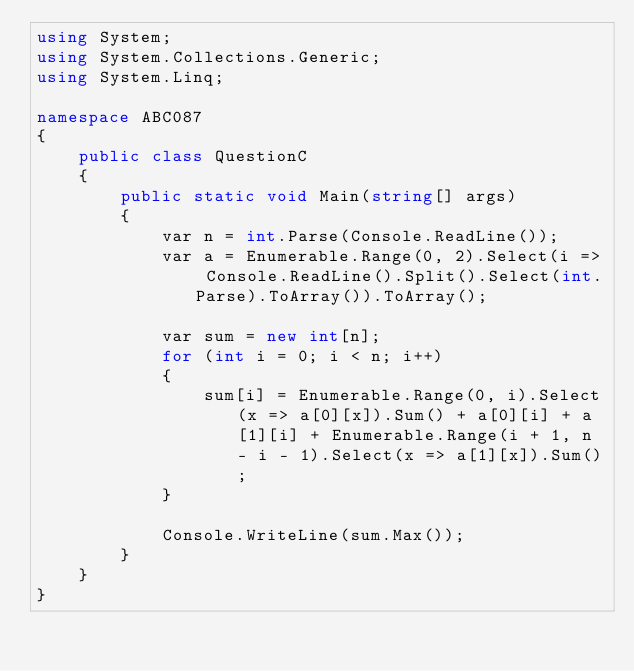<code> <loc_0><loc_0><loc_500><loc_500><_C#_>using System;
using System.Collections.Generic;
using System.Linq;

namespace ABC087
{
    public class QuestionC
    {
        public static void Main(string[] args)
        {
            var n = int.Parse(Console.ReadLine());
            var a = Enumerable.Range(0, 2).Select(i => Console.ReadLine().Split().Select(int.Parse).ToArray()).ToArray();

            var sum = new int[n];
            for (int i = 0; i < n; i++)
            {
                sum[i] = Enumerable.Range(0, i).Select(x => a[0][x]).Sum() + a[0][i] + a[1][i] + Enumerable.Range(i + 1, n - i - 1).Select(x => a[1][x]).Sum();
            }

            Console.WriteLine(sum.Max());
        }
    }
}
</code> 